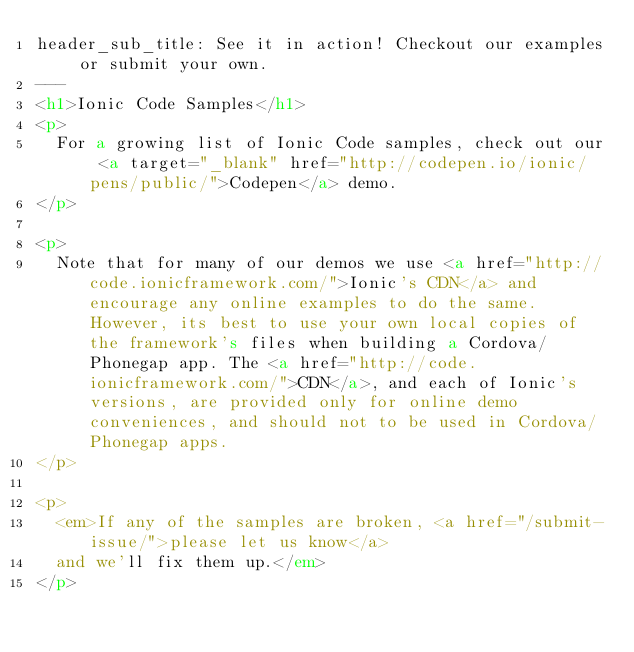Convert code to text. <code><loc_0><loc_0><loc_500><loc_500><_HTML_>header_sub_title: See it in action! Checkout our examples or submit your own.
---
<h1>Ionic Code Samples</h1>
<p>
  For a growing list of Ionic Code samples, check out our <a target="_blank" href="http://codepen.io/ionic/pens/public/">Codepen</a> demo.
</p>

<p>
  Note that for many of our demos we use <a href="http://code.ionicframework.com/">Ionic's CDN</a> and encourage any online examples to do the same. However, its best to use your own local copies of the framework's files when building a Cordova/Phonegap app. The <a href="http://code.ionicframework.com/">CDN</a>, and each of Ionic's versions, are provided only for online demo conveniences, and should not to be used in Cordova/Phonegap apps.
</p>

<p>
  <em>If any of the samples are broken, <a href="/submit-issue/">please let us know</a>
  and we'll fix them up.</em>
</p>

</code> 